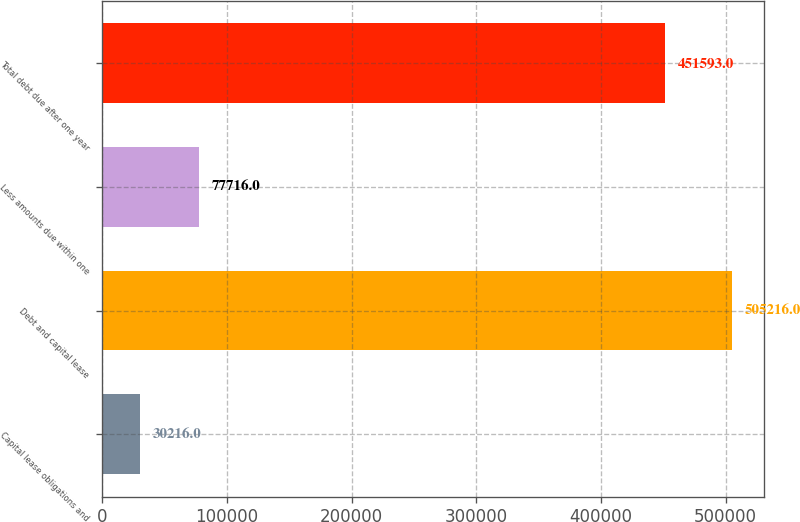Convert chart to OTSL. <chart><loc_0><loc_0><loc_500><loc_500><bar_chart><fcel>Capital lease obligations and<fcel>Debt and capital lease<fcel>Less amounts due within one<fcel>Total debt due after one year<nl><fcel>30216<fcel>505216<fcel>77716<fcel>451593<nl></chart> 